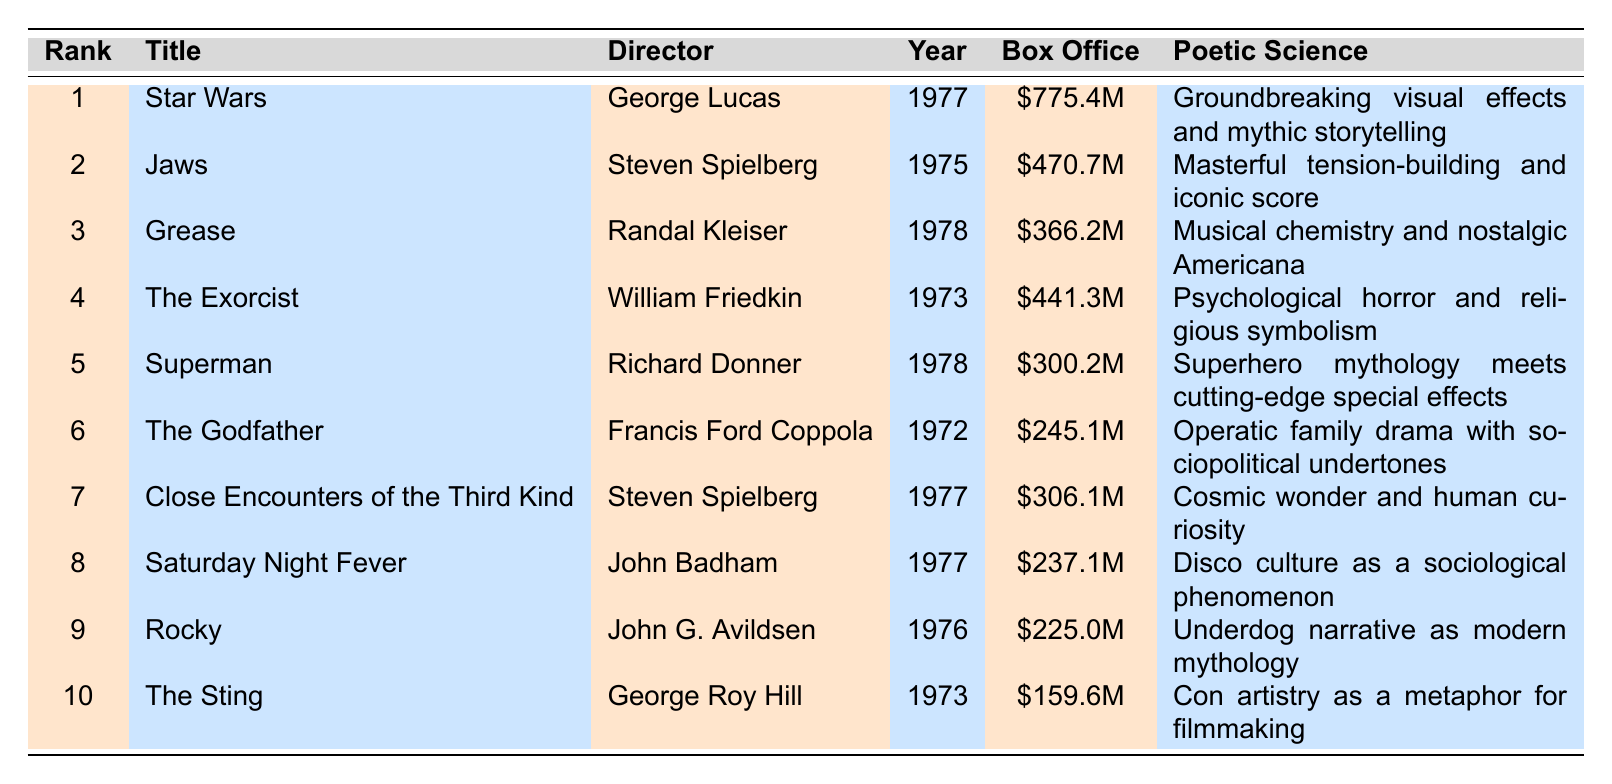What is the title of the highest-grossing film of the 1970s? The table indicates that the film with the highest box office earnings is "Star Wars," which is ranked first.
Answer: Star Wars Who directed "Jaws"? According to the table, "Jaws" was directed by Steven Spielberg.
Answer: Steven Spielberg What year was "The Exorcist" released? The table shows that "The Exorcist" was released in the year 1973.
Answer: 1973 Which film had a box office revenue of over $300 million but less than $400 million? In the table, "Superman" has a box office revenue of $300.2 million, and "Close Encounters of the Third Kind" has $306.1 million, both fitting within this range.
Answer: Superman, Close Encounters of the Third Kind How many films directed by Steven Spielberg are in the top 10 list? The table indicates that there are two films directed by Steven Spielberg: "Jaws" and "Close Encounters of the Third Kind."
Answer: 2 Is "Rocky" ranked higher than "The Godfather"? By comparing ranks in the table, "Rocky" is ranked 9th while "The Godfather" is 6th, indicating "Rocky" is ranked lower.
Answer: No What is the average box office revenue of the films directed by George Lucas? The films by George Lucas in the table are "Star Wars" with $775.4 million and "The Sting" with $159.6 million. The total is $775.4 + $159.6 = $935 million. Dividing by 2 gives an average of $935 million / 2 = $467.5 million.
Answer: $467.5 million Which film had a higher box office: "Grease" or "Superman"? The table shows "Grease" earned $366.2 million, while "Superman" earned $300.2 million, therefore, "Grease" had the higher box office.
Answer: Grease What is the difference in box office earnings between "Jaws" and "The Exorcist"? The earnings of "Jaws" are $470.7 million and "The Exorcist" are $441.3 million. The difference is $470.7 - $441.3 = $29.4 million.
Answer: $29.4 million Was "Saturday Night Fever" released before "Superman"? The release year for "Saturday Night Fever" is 1977 and for "Superman" is 1978, indicating "Saturday Night Fever" was released before "Superman."
Answer: Yes 